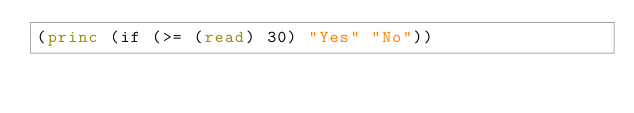Convert code to text. <code><loc_0><loc_0><loc_500><loc_500><_Lisp_>(princ (if (>= (read) 30) "Yes" "No"))</code> 